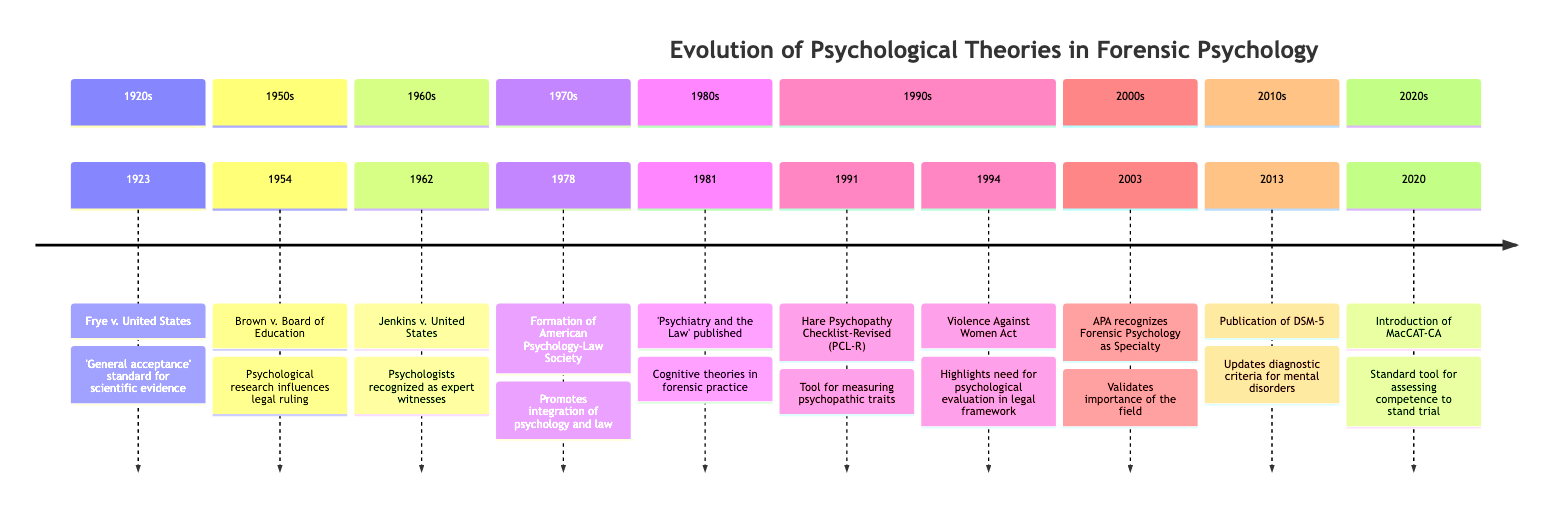What event occurred in 1923? The diagram shows the event "Frye v. United States" listed under the year 1923.
Answer: Frye v. United States How many events are listed in the 1990s? By counting the events shown in the 1990s section of the timeline, there are two events: the "Hare Psychopathy Checklist-Revised (PCL-R)" (1991) and the "Violence Against Women Act" (1994).
Answer: 2 What significant legal case was recognized in 1962? The timeline indicates "Jenkins v. United States" as the event recognized in 1962.
Answer: Jenkins v. United States Which publication was released in 1981? The event listed under 1981 states the publication of "Psychiatry and the Law" by Simon and Aaron T. Beck.
Answer: Psychiatry and the Law What year did the APA officially recognize Forensic Psychology as a specialty? According to the timeline, the year when the APA recognized Forensic Psychology as a specialty is 2003.
Answer: 2003 Which event demonstrates the influence of psychological research in a court ruling? Referring to the timeline, "Brown v. Board of Education" from 1954 illustrates the influence of psychological research in legal judgment.
Answer: Brown v. Board of Education In what year was the MacCAT-CA introduced? The diagram shows "Introduction of the MacCAT-CA" occurring in the year 2020.
Answer: 2020 What does the Hare Psychopathy Checklist-Revised measure? The timeline states that the "Hare Psychopathy Checklist-Revised (PCL-R)" is a tool for measuring psychopathic traits.
Answer: Psychopathic traits Which major legislation highlighted the need for psychological evaluation within the legal framework in 1994? The timeline specifies the "Violence Against Women Act" as the major legislation enacted in 1994 related to psychological evaluation in legal contexts.
Answer: Violence Against Women Act 